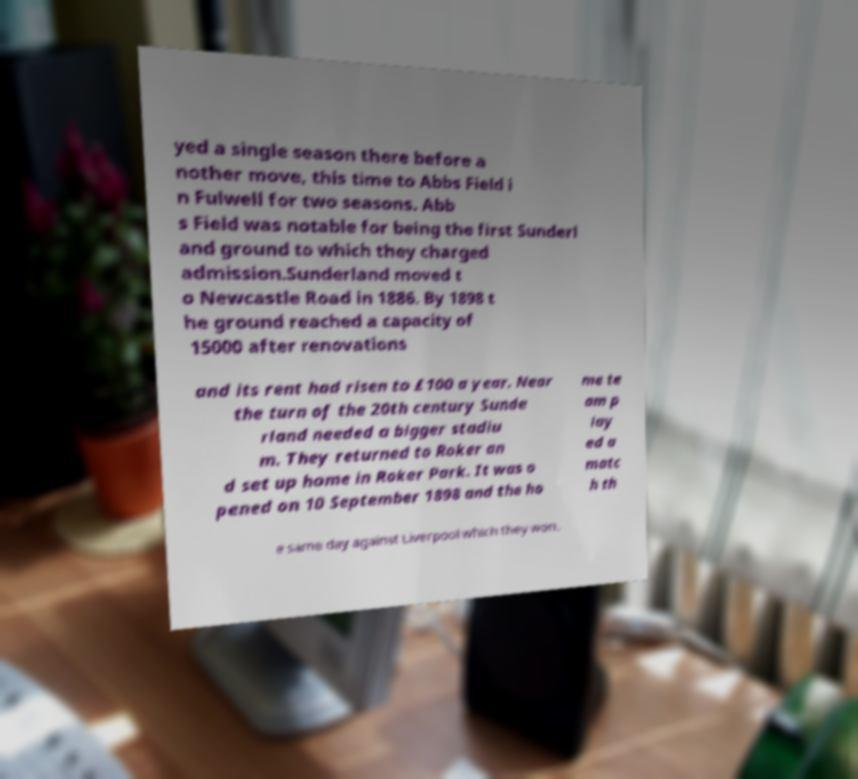There's text embedded in this image that I need extracted. Can you transcribe it verbatim? yed a single season there before a nother move, this time to Abbs Field i n Fulwell for two seasons. Abb s Field was notable for being the first Sunderl and ground to which they charged admission.Sunderland moved t o Newcastle Road in 1886. By 1898 t he ground reached a capacity of 15000 after renovations and its rent had risen to £100 a year. Near the turn of the 20th century Sunde rland needed a bigger stadiu m. They returned to Roker an d set up home in Roker Park. It was o pened on 10 September 1898 and the ho me te am p lay ed a matc h th e same day against Liverpool which they won. 